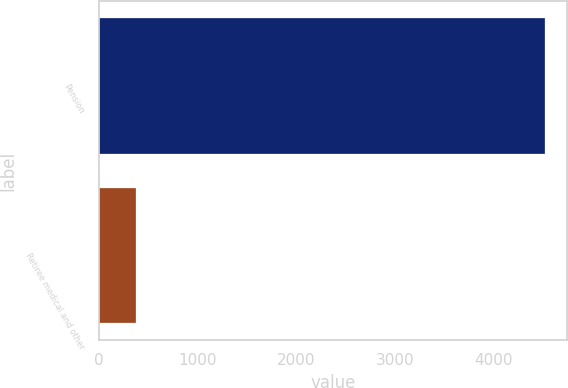Convert chart to OTSL. <chart><loc_0><loc_0><loc_500><loc_500><bar_chart><fcel>Pension<fcel>Retiree medical and other<nl><fcel>4515<fcel>374<nl></chart> 